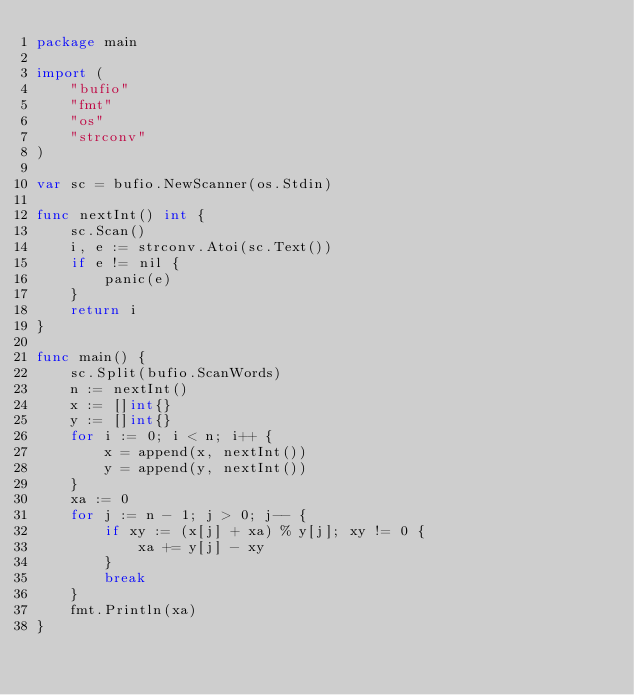<code> <loc_0><loc_0><loc_500><loc_500><_Go_>package main

import (
	"bufio"
	"fmt"
	"os"
	"strconv"
)

var sc = bufio.NewScanner(os.Stdin)

func nextInt() int {
	sc.Scan()
	i, e := strconv.Atoi(sc.Text())
	if e != nil {
		panic(e)
	}
	return i
}

func main() {
	sc.Split(bufio.ScanWords)
	n := nextInt()
	x := []int{}
	y := []int{}
	for i := 0; i < n; i++ {
		x = append(x, nextInt())
		y = append(y, nextInt())
	}
	xa := 0
	for j := n - 1; j > 0; j-- {
		if xy := (x[j] + xa) % y[j]; xy != 0 {
			xa += y[j] - xy
		}
		break
	}
	fmt.Println(xa)
}
</code> 